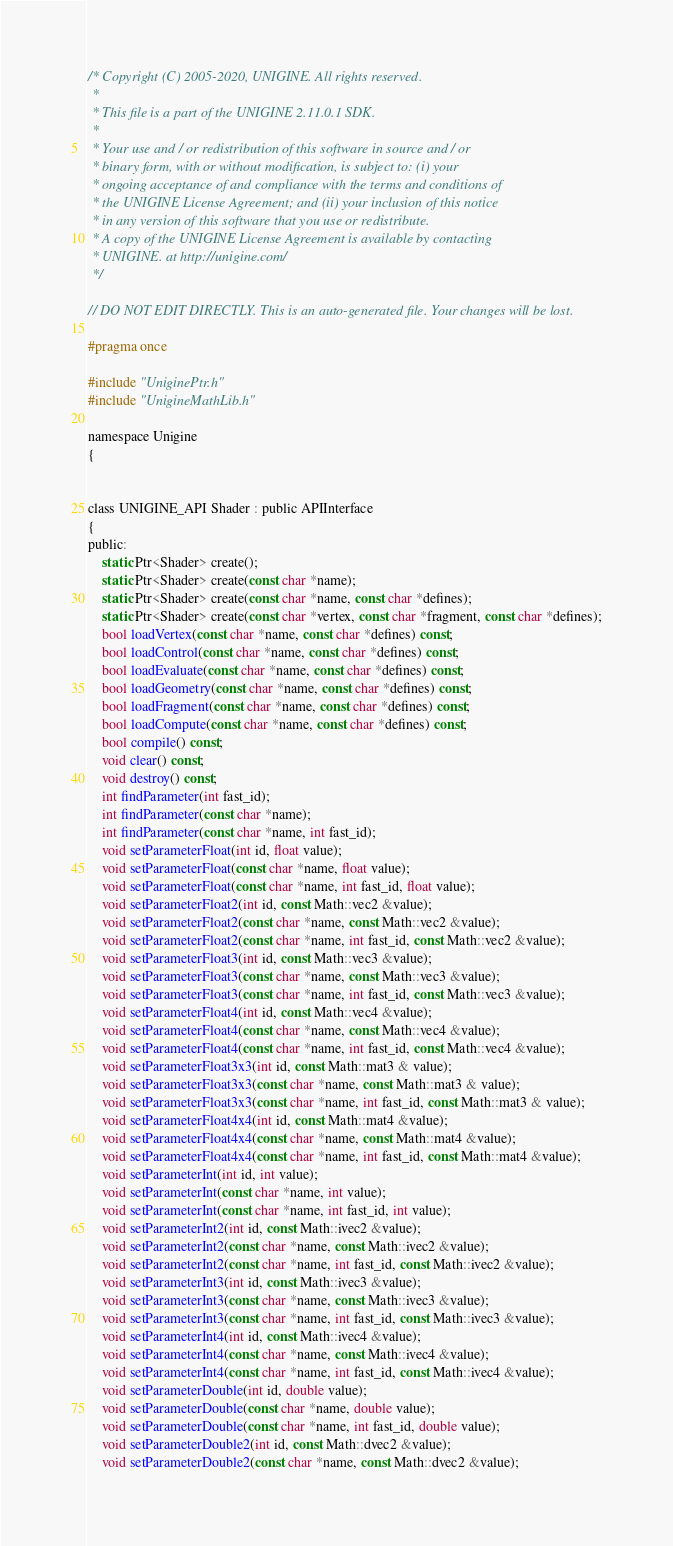<code> <loc_0><loc_0><loc_500><loc_500><_C_>/* Copyright (C) 2005-2020, UNIGINE. All rights reserved.
 *
 * This file is a part of the UNIGINE 2.11.0.1 SDK.
 *
 * Your use and / or redistribution of this software in source and / or
 * binary form, with or without modification, is subject to: (i) your
 * ongoing acceptance of and compliance with the terms and conditions of
 * the UNIGINE License Agreement; and (ii) your inclusion of this notice
 * in any version of this software that you use or redistribute.
 * A copy of the UNIGINE License Agreement is available by contacting
 * UNIGINE. at http://unigine.com/
 */

// DO NOT EDIT DIRECTLY. This is an auto-generated file. Your changes will be lost.

#pragma once

#include "UniginePtr.h"
#include "UnigineMathLib.h"

namespace Unigine
{


class UNIGINE_API Shader : public APIInterface
{
public:
	static Ptr<Shader> create();
	static Ptr<Shader> create(const char *name);
	static Ptr<Shader> create(const char *name, const char *defines);
	static Ptr<Shader> create(const char *vertex, const char *fragment, const char *defines);
	bool loadVertex(const char *name, const char *defines) const;
	bool loadControl(const char *name, const char *defines) const;
	bool loadEvaluate(const char *name, const char *defines) const;
	bool loadGeometry(const char *name, const char *defines) const;
	bool loadFragment(const char *name, const char *defines) const;
	bool loadCompute(const char *name, const char *defines) const;
	bool compile() const;
	void clear() const;
	void destroy() const;
	int findParameter(int fast_id);
	int findParameter(const char *name);
	int findParameter(const char *name, int fast_id);
	void setParameterFloat(int id, float value);
	void setParameterFloat(const char *name, float value);
	void setParameterFloat(const char *name, int fast_id, float value);
	void setParameterFloat2(int id, const Math::vec2 &value);
	void setParameterFloat2(const char *name, const Math::vec2 &value);
	void setParameterFloat2(const char *name, int fast_id, const Math::vec2 &value);
	void setParameterFloat3(int id, const Math::vec3 &value);
	void setParameterFloat3(const char *name, const Math::vec3 &value);
	void setParameterFloat3(const char *name, int fast_id, const Math::vec3 &value);
	void setParameterFloat4(int id, const Math::vec4 &value);
	void setParameterFloat4(const char *name, const Math::vec4 &value);
	void setParameterFloat4(const char *name, int fast_id, const Math::vec4 &value);
	void setParameterFloat3x3(int id, const Math::mat3 & value);
	void setParameterFloat3x3(const char *name, const Math::mat3 & value);
	void setParameterFloat3x3(const char *name, int fast_id, const Math::mat3 & value);
	void setParameterFloat4x4(int id, const Math::mat4 &value);
	void setParameterFloat4x4(const char *name, const Math::mat4 &value);
	void setParameterFloat4x4(const char *name, int fast_id, const Math::mat4 &value);
	void setParameterInt(int id, int value);
	void setParameterInt(const char *name, int value);
	void setParameterInt(const char *name, int fast_id, int value);
	void setParameterInt2(int id, const Math::ivec2 &value);
	void setParameterInt2(const char *name, const Math::ivec2 &value);
	void setParameterInt2(const char *name, int fast_id, const Math::ivec2 &value);
	void setParameterInt3(int id, const Math::ivec3 &value);
	void setParameterInt3(const char *name, const Math::ivec3 &value);
	void setParameterInt3(const char *name, int fast_id, const Math::ivec3 &value);
	void setParameterInt4(int id, const Math::ivec4 &value);
	void setParameterInt4(const char *name, const Math::ivec4 &value);
	void setParameterInt4(const char *name, int fast_id, const Math::ivec4 &value);
	void setParameterDouble(int id, double value);
	void setParameterDouble(const char *name, double value);
	void setParameterDouble(const char *name, int fast_id, double value);
	void setParameterDouble2(int id, const Math::dvec2 &value);
	void setParameterDouble2(const char *name, const Math::dvec2 &value);</code> 